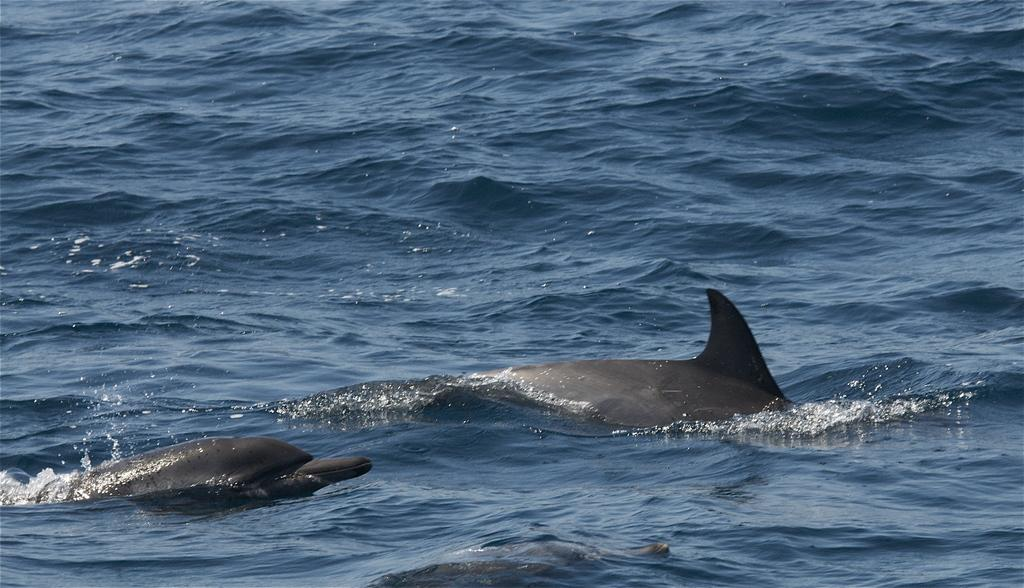What animals can be seen in the image? There are dolphins in the image. Where are the dolphins located? The dolphins are swimming in the sea. What type of bun is being used to feed the dolphins in the image? There is no bun present in the image, as the dolphins are swimming in the sea and not being fed. 